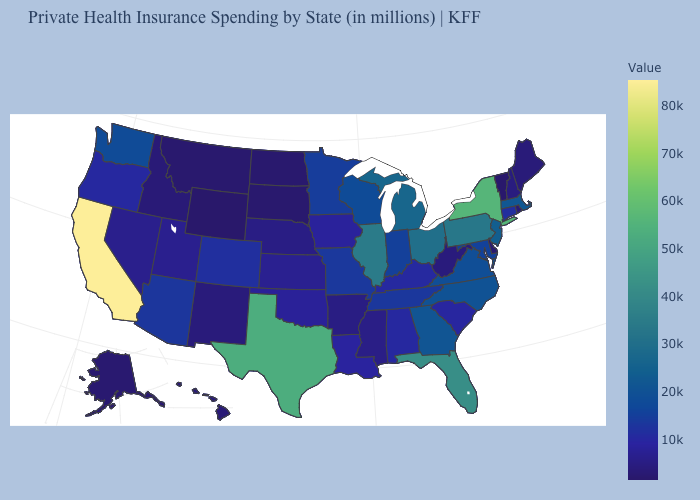Is the legend a continuous bar?
Answer briefly. Yes. Among the states that border Rhode Island , does Connecticut have the lowest value?
Answer briefly. Yes. Does Colorado have the highest value in the USA?
Write a very short answer. No. Which states have the lowest value in the South?
Quick response, please. Delaware. Does California have the highest value in the West?
Concise answer only. Yes. Is the legend a continuous bar?
Give a very brief answer. Yes. 